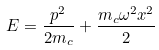<formula> <loc_0><loc_0><loc_500><loc_500>E = \frac { p ^ { 2 } } { 2 m _ { c } } + \frac { m _ { c } \omega ^ { 2 } x ^ { 2 } } { 2 }</formula> 